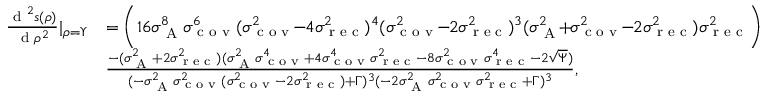Convert formula to latex. <formula><loc_0><loc_0><loc_500><loc_500>\begin{array} { r l } { \frac { d ^ { 2 } s ( \rho ) } { d \rho ^ { 2 } } | _ { \rho = \Upsilon } } & { = \left ( 1 6 \sigma _ { A } ^ { 8 } \sigma _ { c o v } ^ { 6 } ( \sigma _ { c o v } ^ { 2 } \, - \, 4 \sigma _ { r e c } ^ { 2 } ) ^ { 4 } ( \sigma _ { c o v } ^ { 2 } \, - \, 2 \sigma _ { r e c } ^ { 2 } ) ^ { 3 } ( \sigma _ { A } ^ { 2 } \, + \, \sigma _ { c o v } ^ { 2 } \, - \, 2 \sigma _ { r e c } ^ { 2 } ) \sigma _ { r e c } ^ { 2 } \right ) } \\ & { \frac { - ( \sigma _ { A } ^ { 2 } + 2 \sigma _ { r e c } ^ { 2 } ) ( \sigma _ { A } ^ { 2 } \sigma _ { c o v } ^ { 4 } + 4 \sigma _ { c o v } ^ { 4 } \sigma _ { r e c } ^ { 2 } - 8 \sigma _ { c o v } ^ { 2 } \sigma _ { r e c } ^ { 4 } - 2 \sqrt { \Psi } ) } { ( - \sigma _ { A } ^ { 2 } \sigma _ { c o v } ^ { 2 } ( \sigma _ { c o v } ^ { 2 } - 2 \sigma _ { r e c } ^ { 2 } ) + \Gamma ) ^ { 3 } ( - 2 \sigma _ { A } ^ { 2 } \sigma _ { c o v } ^ { 2 } \sigma _ { r e c } ^ { 2 } + \Gamma ) ^ { 3 } } , } \end{array}</formula> 